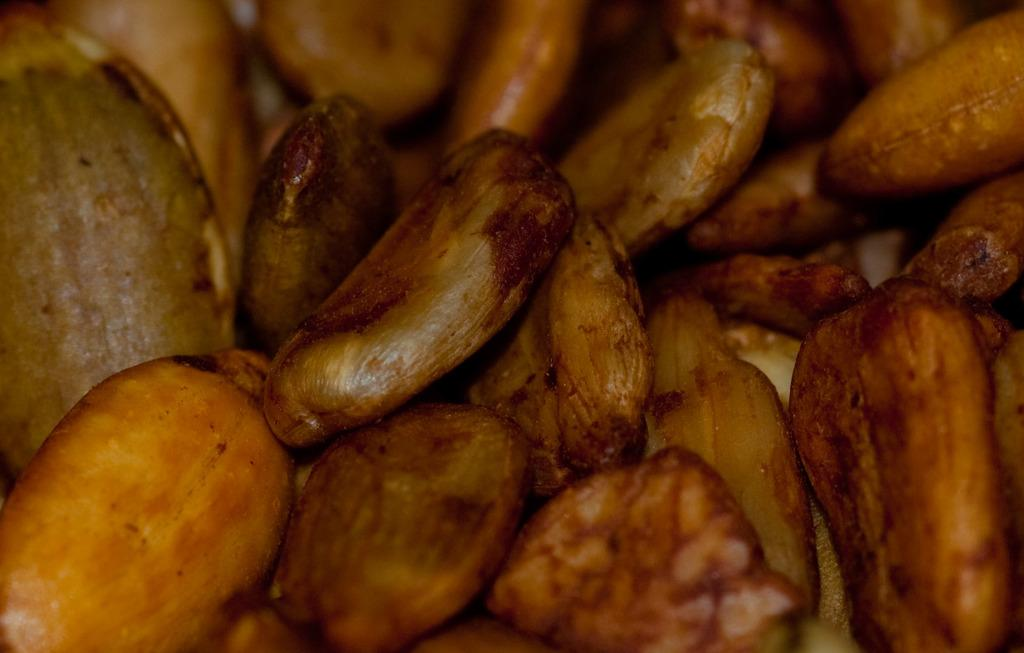What type of objects are present in the image? There are seeds in the image. Can you describe the colors of the seeds? The seeds have yellow and reddish colors, and some seeds are green in color. How many clocks are visible in the image? There are no clocks present in the image. What is the size of the seeds in the image? The size of the seeds cannot be determined from the image alone, as there is no reference for scale. 